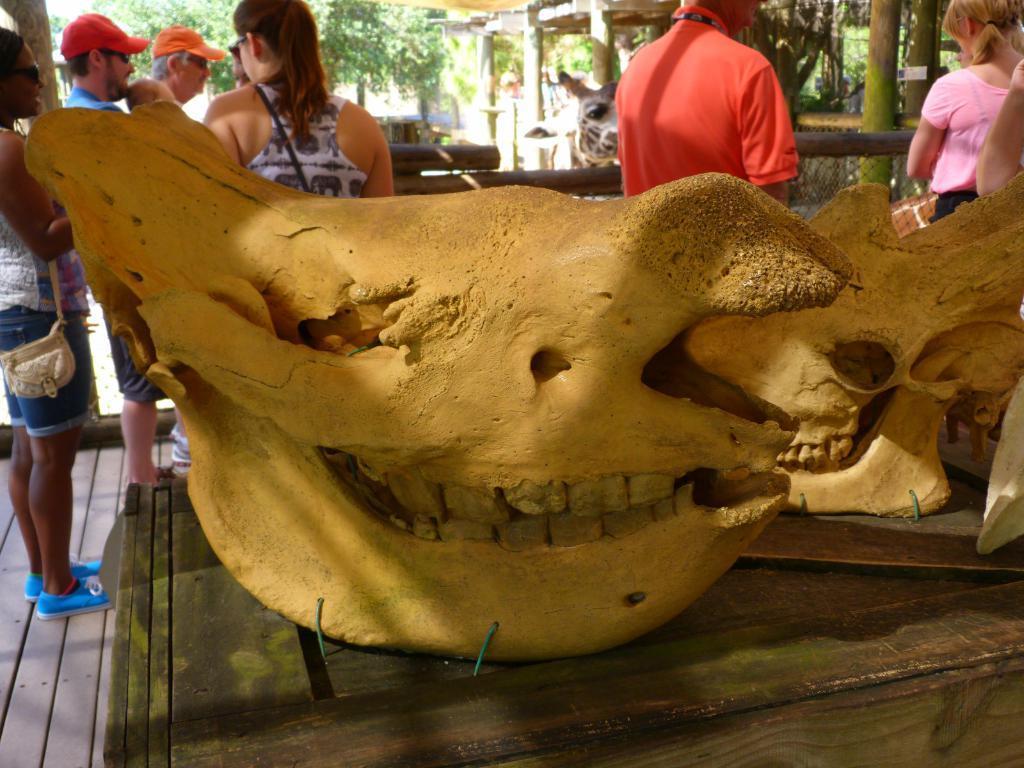Describe this image in one or two sentences. In this picture there are bones of an animal are placed on the table. Towards the left, there is a woman carrying a bag. Before her, there are people. In the center, there is a giraffe. Before it, there is a person wearing an orange t shirt. Towards the right there are people. In the background there are trees. 